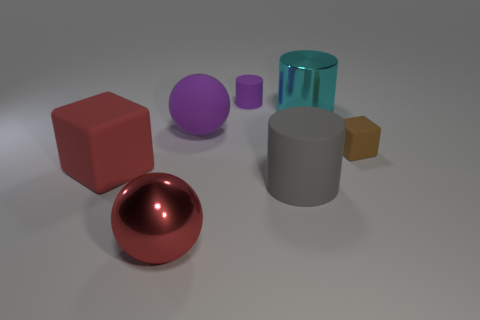The purple ball that is made of the same material as the gray cylinder is what size?
Ensure brevity in your answer.  Large. Is the material of the small brown thing the same as the cyan cylinder?
Offer a terse response. No. How many other things are made of the same material as the gray cylinder?
Provide a short and direct response. 4. What number of things are both to the left of the small cylinder and behind the tiny matte block?
Give a very brief answer. 1. The big shiny sphere has what color?
Your answer should be compact. Red. There is a small purple thing that is the same shape as the gray object; what is it made of?
Provide a short and direct response. Rubber. Is the color of the large metallic ball the same as the large matte block?
Offer a terse response. Yes. There is a large matte thing behind the big matte thing that is to the left of the large red ball; what is its shape?
Keep it short and to the point. Sphere. There is a small purple thing that is made of the same material as the tiny brown cube; what shape is it?
Provide a succinct answer. Cylinder. What number of other objects are there of the same shape as the gray rubber thing?
Ensure brevity in your answer.  2. 